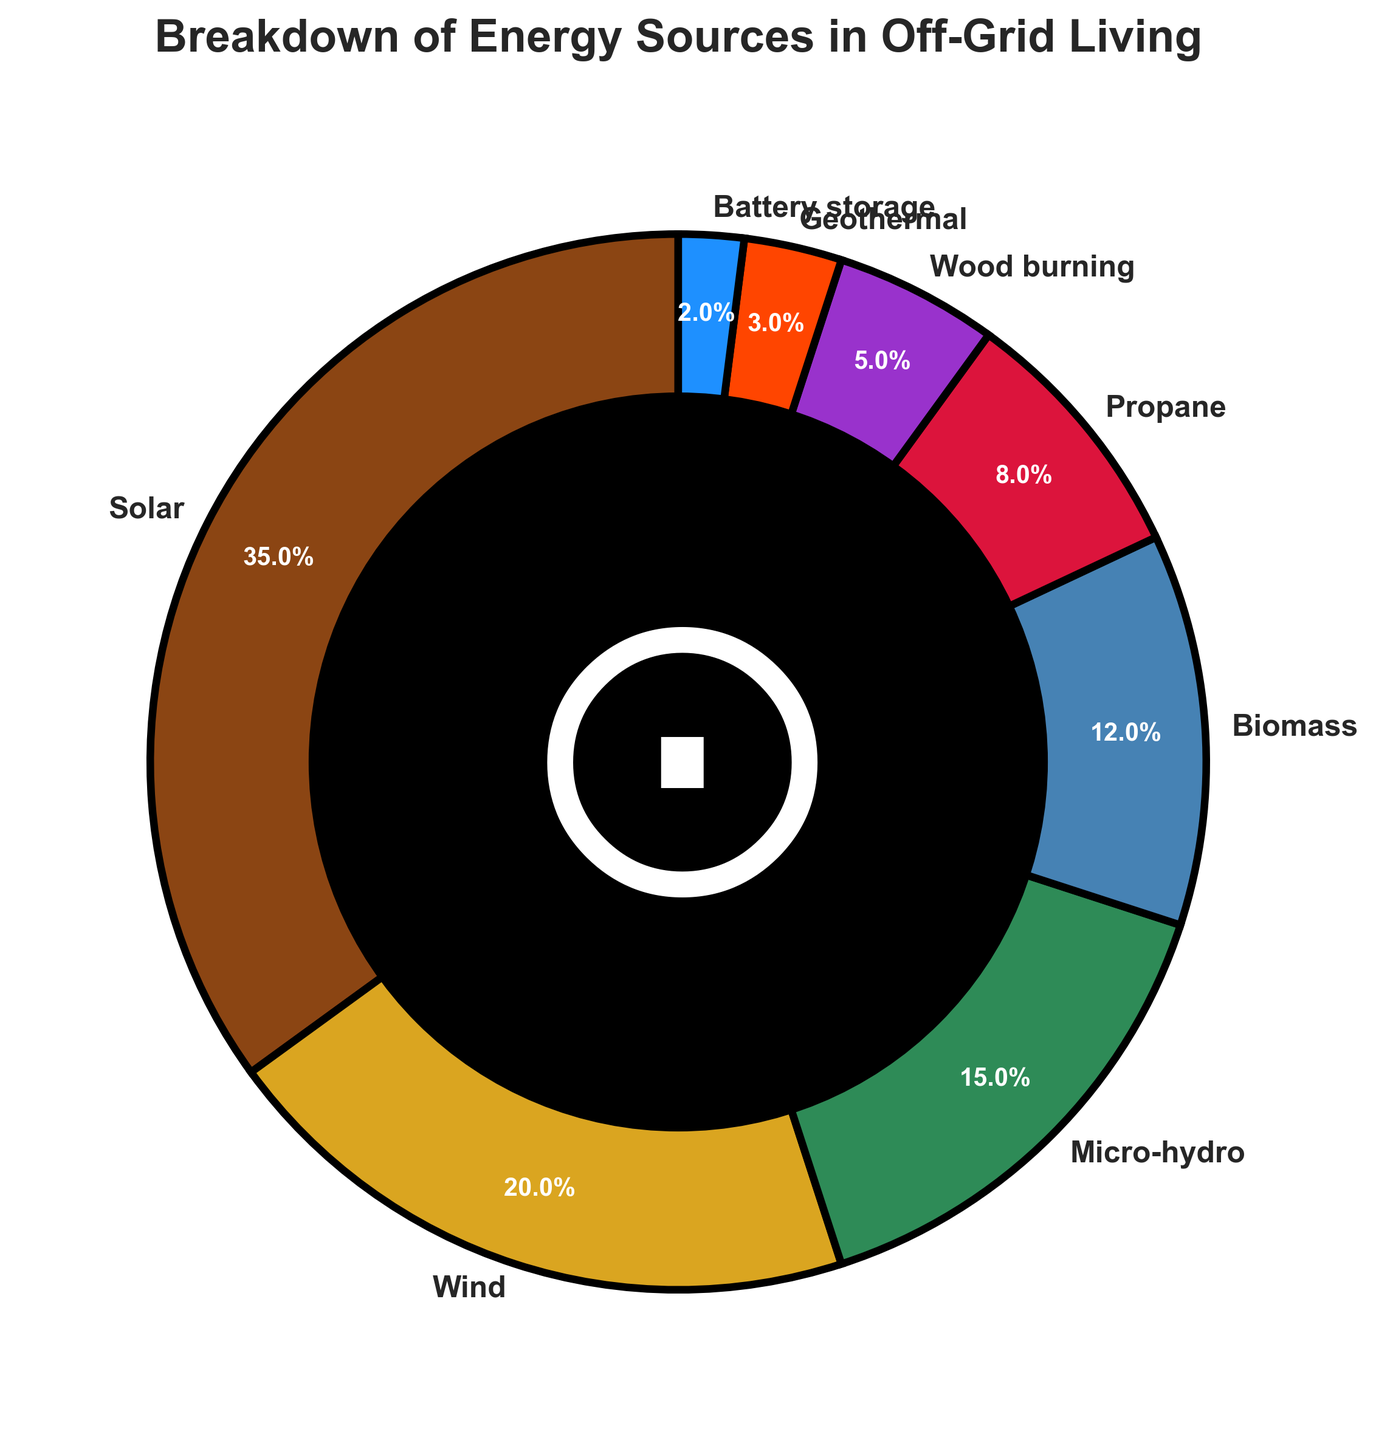What percentage of the energy sources is provided by Solar and Wind combined? To calculate the combined percentage, sum the percentage values for Solar and Wind. Solar provides 35%, and Wind provides 20%. Adding these percentages results in 35 + 20 = 55%.
Answer: 55% Which energy source has the smallest contribution? By examining the pie chart, the label with the smallest percentage can be identified. It is Battery storage with 2%.
Answer: Battery storage How much greater is the percentage of Solar compared to Geothermal? Subtract the percentage of Geothermal from the percentage of Solar. Solar provides 35% and Geothermal provides 3%. The difference is 35 - 3 = 32%.
Answer: 32% What is the combined percentage for Micro-hydro and Biomass? To find the combined percentage, sum the values for Micro-hydro and Biomass. Micro-hydro is 15%, and Biomass is 12%. Adding them results in 15 + 12 = 27%.
Answer: 27% Which energy sources are represented by shades of green or blue? The colors associated with the slices can be cross-checked with their corresponding source labels. Wind (gold), Micro-hydro (teal-ish), and Biomass (green-ish blue) are approximately shades of green or blue.
Answer: Wind and Micro-hydro Is the contribution of Propane greater than or equal to Wood burning? By comparing the labels, Propane is 8% and Wood burning is 5%. Propane's contribution is indeed greater than Wood burning.
Answer: Yes Which sources together make up exactly 50%? Inspect the chart for combinations totalling 50%. Solar (35%) and Micro-hydro (15%) add up to 50%.
Answer: Solar and Micro-hydro What visual element is in the center of the pie chart? Observing the center of the chart, there is a black circle added with a mystical symbol inside it, resembling a ring.
Answer: Black circle with a mystical symbol 